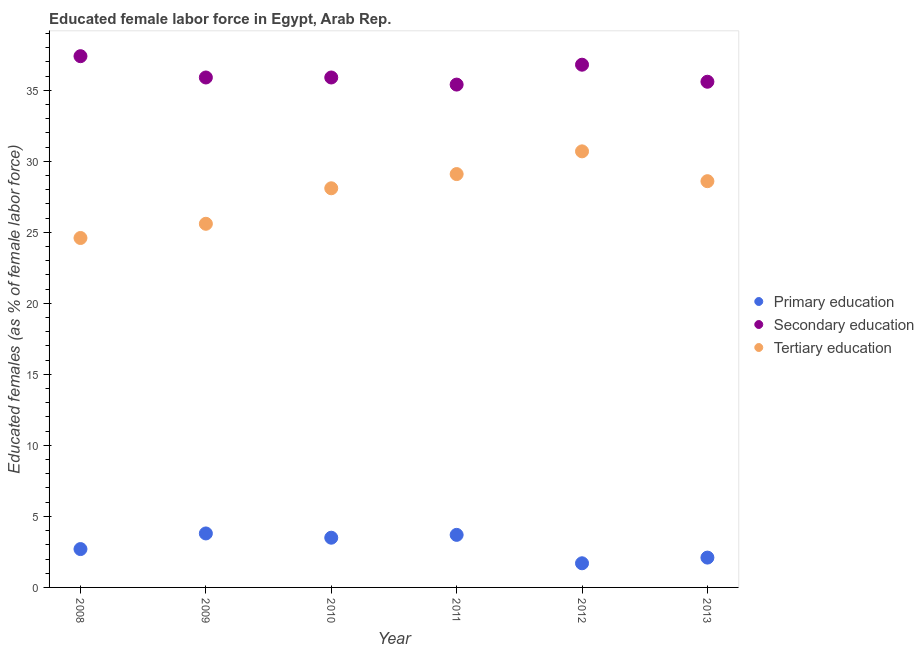Is the number of dotlines equal to the number of legend labels?
Make the answer very short. Yes. What is the percentage of female labor force who received tertiary education in 2012?
Your answer should be compact. 30.7. Across all years, what is the maximum percentage of female labor force who received secondary education?
Keep it short and to the point. 37.4. Across all years, what is the minimum percentage of female labor force who received tertiary education?
Offer a very short reply. 24.6. In which year was the percentage of female labor force who received tertiary education maximum?
Your response must be concise. 2012. What is the total percentage of female labor force who received tertiary education in the graph?
Your response must be concise. 166.7. What is the difference between the percentage of female labor force who received primary education in 2008 and that in 2013?
Offer a very short reply. 0.6. What is the difference between the percentage of female labor force who received secondary education in 2012 and the percentage of female labor force who received tertiary education in 2009?
Keep it short and to the point. 11.2. What is the average percentage of female labor force who received tertiary education per year?
Provide a succinct answer. 27.78. In the year 2013, what is the difference between the percentage of female labor force who received tertiary education and percentage of female labor force who received secondary education?
Keep it short and to the point. -7. In how many years, is the percentage of female labor force who received primary education greater than 2 %?
Your answer should be compact. 5. What is the ratio of the percentage of female labor force who received tertiary education in 2009 to that in 2012?
Your response must be concise. 0.83. What is the difference between the highest and the second highest percentage of female labor force who received tertiary education?
Your answer should be compact. 1.6. What is the difference between the highest and the lowest percentage of female labor force who received primary education?
Offer a very short reply. 2.1. In how many years, is the percentage of female labor force who received tertiary education greater than the average percentage of female labor force who received tertiary education taken over all years?
Your answer should be compact. 4. Is the sum of the percentage of female labor force who received primary education in 2009 and 2012 greater than the maximum percentage of female labor force who received secondary education across all years?
Provide a short and direct response. No. Is it the case that in every year, the sum of the percentage of female labor force who received primary education and percentage of female labor force who received secondary education is greater than the percentage of female labor force who received tertiary education?
Your answer should be very brief. Yes. Is the percentage of female labor force who received primary education strictly greater than the percentage of female labor force who received secondary education over the years?
Provide a succinct answer. No. Is the percentage of female labor force who received secondary education strictly less than the percentage of female labor force who received tertiary education over the years?
Keep it short and to the point. No. What is the difference between two consecutive major ticks on the Y-axis?
Offer a terse response. 5. Does the graph contain any zero values?
Offer a very short reply. No. Does the graph contain grids?
Provide a succinct answer. No. How are the legend labels stacked?
Provide a succinct answer. Vertical. What is the title of the graph?
Your response must be concise. Educated female labor force in Egypt, Arab Rep. What is the label or title of the X-axis?
Provide a succinct answer. Year. What is the label or title of the Y-axis?
Offer a terse response. Educated females (as % of female labor force). What is the Educated females (as % of female labor force) in Primary education in 2008?
Offer a very short reply. 2.7. What is the Educated females (as % of female labor force) in Secondary education in 2008?
Provide a succinct answer. 37.4. What is the Educated females (as % of female labor force) in Tertiary education in 2008?
Your answer should be compact. 24.6. What is the Educated females (as % of female labor force) in Primary education in 2009?
Offer a terse response. 3.8. What is the Educated females (as % of female labor force) in Secondary education in 2009?
Your answer should be very brief. 35.9. What is the Educated females (as % of female labor force) of Tertiary education in 2009?
Offer a very short reply. 25.6. What is the Educated females (as % of female labor force) in Primary education in 2010?
Make the answer very short. 3.5. What is the Educated females (as % of female labor force) of Secondary education in 2010?
Offer a terse response. 35.9. What is the Educated females (as % of female labor force) of Tertiary education in 2010?
Make the answer very short. 28.1. What is the Educated females (as % of female labor force) in Primary education in 2011?
Provide a short and direct response. 3.7. What is the Educated females (as % of female labor force) of Secondary education in 2011?
Ensure brevity in your answer.  35.4. What is the Educated females (as % of female labor force) in Tertiary education in 2011?
Your answer should be very brief. 29.1. What is the Educated females (as % of female labor force) in Primary education in 2012?
Provide a short and direct response. 1.7. What is the Educated females (as % of female labor force) in Secondary education in 2012?
Offer a very short reply. 36.8. What is the Educated females (as % of female labor force) of Tertiary education in 2012?
Ensure brevity in your answer.  30.7. What is the Educated females (as % of female labor force) in Primary education in 2013?
Your answer should be very brief. 2.1. What is the Educated females (as % of female labor force) of Secondary education in 2013?
Offer a very short reply. 35.6. What is the Educated females (as % of female labor force) in Tertiary education in 2013?
Provide a succinct answer. 28.6. Across all years, what is the maximum Educated females (as % of female labor force) of Primary education?
Provide a short and direct response. 3.8. Across all years, what is the maximum Educated females (as % of female labor force) of Secondary education?
Make the answer very short. 37.4. Across all years, what is the maximum Educated females (as % of female labor force) of Tertiary education?
Your response must be concise. 30.7. Across all years, what is the minimum Educated females (as % of female labor force) of Primary education?
Offer a terse response. 1.7. Across all years, what is the minimum Educated females (as % of female labor force) in Secondary education?
Your answer should be compact. 35.4. Across all years, what is the minimum Educated females (as % of female labor force) of Tertiary education?
Ensure brevity in your answer.  24.6. What is the total Educated females (as % of female labor force) in Primary education in the graph?
Offer a very short reply. 17.5. What is the total Educated females (as % of female labor force) in Secondary education in the graph?
Provide a succinct answer. 217. What is the total Educated females (as % of female labor force) in Tertiary education in the graph?
Offer a very short reply. 166.7. What is the difference between the Educated females (as % of female labor force) of Primary education in 2008 and that in 2010?
Offer a very short reply. -0.8. What is the difference between the Educated females (as % of female labor force) of Tertiary education in 2008 and that in 2010?
Your response must be concise. -3.5. What is the difference between the Educated females (as % of female labor force) in Secondary education in 2008 and that in 2011?
Provide a short and direct response. 2. What is the difference between the Educated females (as % of female labor force) in Tertiary education in 2008 and that in 2011?
Your answer should be compact. -4.5. What is the difference between the Educated females (as % of female labor force) in Secondary education in 2008 and that in 2012?
Keep it short and to the point. 0.6. What is the difference between the Educated females (as % of female labor force) of Tertiary education in 2008 and that in 2012?
Your response must be concise. -6.1. What is the difference between the Educated females (as % of female labor force) in Secondary education in 2008 and that in 2013?
Your response must be concise. 1.8. What is the difference between the Educated females (as % of female labor force) of Primary education in 2009 and that in 2010?
Offer a terse response. 0.3. What is the difference between the Educated females (as % of female labor force) in Primary education in 2009 and that in 2011?
Provide a succinct answer. 0.1. What is the difference between the Educated females (as % of female labor force) in Tertiary education in 2009 and that in 2011?
Provide a succinct answer. -3.5. What is the difference between the Educated females (as % of female labor force) in Primary education in 2009 and that in 2012?
Give a very brief answer. 2.1. What is the difference between the Educated females (as % of female labor force) in Secondary education in 2009 and that in 2012?
Offer a terse response. -0.9. What is the difference between the Educated females (as % of female labor force) of Primary education in 2009 and that in 2013?
Give a very brief answer. 1.7. What is the difference between the Educated females (as % of female labor force) in Secondary education in 2009 and that in 2013?
Provide a short and direct response. 0.3. What is the difference between the Educated females (as % of female labor force) in Secondary education in 2010 and that in 2011?
Offer a terse response. 0.5. What is the difference between the Educated females (as % of female labor force) in Primary education in 2010 and that in 2012?
Your response must be concise. 1.8. What is the difference between the Educated females (as % of female labor force) in Tertiary education in 2010 and that in 2012?
Provide a succinct answer. -2.6. What is the difference between the Educated females (as % of female labor force) of Tertiary education in 2010 and that in 2013?
Your response must be concise. -0.5. What is the difference between the Educated females (as % of female labor force) of Primary education in 2011 and that in 2012?
Give a very brief answer. 2. What is the difference between the Educated females (as % of female labor force) in Secondary education in 2011 and that in 2012?
Offer a very short reply. -1.4. What is the difference between the Educated females (as % of female labor force) of Primary education in 2011 and that in 2013?
Offer a terse response. 1.6. What is the difference between the Educated females (as % of female labor force) of Primary education in 2012 and that in 2013?
Ensure brevity in your answer.  -0.4. What is the difference between the Educated females (as % of female labor force) in Tertiary education in 2012 and that in 2013?
Your answer should be compact. 2.1. What is the difference between the Educated females (as % of female labor force) in Primary education in 2008 and the Educated females (as % of female labor force) in Secondary education in 2009?
Provide a short and direct response. -33.2. What is the difference between the Educated females (as % of female labor force) of Primary education in 2008 and the Educated females (as % of female labor force) of Tertiary education in 2009?
Your response must be concise. -22.9. What is the difference between the Educated females (as % of female labor force) of Secondary education in 2008 and the Educated females (as % of female labor force) of Tertiary education in 2009?
Offer a very short reply. 11.8. What is the difference between the Educated females (as % of female labor force) in Primary education in 2008 and the Educated females (as % of female labor force) in Secondary education in 2010?
Ensure brevity in your answer.  -33.2. What is the difference between the Educated females (as % of female labor force) of Primary education in 2008 and the Educated females (as % of female labor force) of Tertiary education in 2010?
Offer a terse response. -25.4. What is the difference between the Educated females (as % of female labor force) in Primary education in 2008 and the Educated females (as % of female labor force) in Secondary education in 2011?
Offer a terse response. -32.7. What is the difference between the Educated females (as % of female labor force) of Primary education in 2008 and the Educated females (as % of female labor force) of Tertiary education in 2011?
Keep it short and to the point. -26.4. What is the difference between the Educated females (as % of female labor force) in Secondary education in 2008 and the Educated females (as % of female labor force) in Tertiary education in 2011?
Offer a very short reply. 8.3. What is the difference between the Educated females (as % of female labor force) in Primary education in 2008 and the Educated females (as % of female labor force) in Secondary education in 2012?
Make the answer very short. -34.1. What is the difference between the Educated females (as % of female labor force) in Primary education in 2008 and the Educated females (as % of female labor force) in Tertiary education in 2012?
Give a very brief answer. -28. What is the difference between the Educated females (as % of female labor force) in Primary education in 2008 and the Educated females (as % of female labor force) in Secondary education in 2013?
Your answer should be compact. -32.9. What is the difference between the Educated females (as % of female labor force) of Primary education in 2008 and the Educated females (as % of female labor force) of Tertiary education in 2013?
Provide a succinct answer. -25.9. What is the difference between the Educated females (as % of female labor force) in Secondary education in 2008 and the Educated females (as % of female labor force) in Tertiary education in 2013?
Provide a short and direct response. 8.8. What is the difference between the Educated females (as % of female labor force) of Primary education in 2009 and the Educated females (as % of female labor force) of Secondary education in 2010?
Make the answer very short. -32.1. What is the difference between the Educated females (as % of female labor force) of Primary education in 2009 and the Educated females (as % of female labor force) of Tertiary education in 2010?
Provide a succinct answer. -24.3. What is the difference between the Educated females (as % of female labor force) in Primary education in 2009 and the Educated females (as % of female labor force) in Secondary education in 2011?
Your response must be concise. -31.6. What is the difference between the Educated females (as % of female labor force) in Primary education in 2009 and the Educated females (as % of female labor force) in Tertiary education in 2011?
Your answer should be compact. -25.3. What is the difference between the Educated females (as % of female labor force) of Primary education in 2009 and the Educated females (as % of female labor force) of Secondary education in 2012?
Ensure brevity in your answer.  -33. What is the difference between the Educated females (as % of female labor force) in Primary education in 2009 and the Educated females (as % of female labor force) in Tertiary education in 2012?
Offer a very short reply. -26.9. What is the difference between the Educated females (as % of female labor force) of Primary education in 2009 and the Educated females (as % of female labor force) of Secondary education in 2013?
Your answer should be very brief. -31.8. What is the difference between the Educated females (as % of female labor force) of Primary education in 2009 and the Educated females (as % of female labor force) of Tertiary education in 2013?
Your answer should be very brief. -24.8. What is the difference between the Educated females (as % of female labor force) in Primary education in 2010 and the Educated females (as % of female labor force) in Secondary education in 2011?
Provide a succinct answer. -31.9. What is the difference between the Educated females (as % of female labor force) in Primary education in 2010 and the Educated females (as % of female labor force) in Tertiary education in 2011?
Make the answer very short. -25.6. What is the difference between the Educated females (as % of female labor force) of Primary education in 2010 and the Educated females (as % of female labor force) of Secondary education in 2012?
Keep it short and to the point. -33.3. What is the difference between the Educated females (as % of female labor force) of Primary education in 2010 and the Educated females (as % of female labor force) of Tertiary education in 2012?
Your answer should be compact. -27.2. What is the difference between the Educated females (as % of female labor force) of Primary education in 2010 and the Educated females (as % of female labor force) of Secondary education in 2013?
Offer a terse response. -32.1. What is the difference between the Educated females (as % of female labor force) of Primary education in 2010 and the Educated females (as % of female labor force) of Tertiary education in 2013?
Your answer should be compact. -25.1. What is the difference between the Educated females (as % of female labor force) in Secondary education in 2010 and the Educated females (as % of female labor force) in Tertiary education in 2013?
Your answer should be very brief. 7.3. What is the difference between the Educated females (as % of female labor force) in Primary education in 2011 and the Educated females (as % of female labor force) in Secondary education in 2012?
Make the answer very short. -33.1. What is the difference between the Educated females (as % of female labor force) of Primary education in 2011 and the Educated females (as % of female labor force) of Tertiary education in 2012?
Your answer should be compact. -27. What is the difference between the Educated females (as % of female labor force) in Primary education in 2011 and the Educated females (as % of female labor force) in Secondary education in 2013?
Your answer should be compact. -31.9. What is the difference between the Educated females (as % of female labor force) in Primary education in 2011 and the Educated females (as % of female labor force) in Tertiary education in 2013?
Ensure brevity in your answer.  -24.9. What is the difference between the Educated females (as % of female labor force) of Primary education in 2012 and the Educated females (as % of female labor force) of Secondary education in 2013?
Your answer should be compact. -33.9. What is the difference between the Educated females (as % of female labor force) of Primary education in 2012 and the Educated females (as % of female labor force) of Tertiary education in 2013?
Your answer should be very brief. -26.9. What is the average Educated females (as % of female labor force) in Primary education per year?
Give a very brief answer. 2.92. What is the average Educated females (as % of female labor force) of Secondary education per year?
Make the answer very short. 36.17. What is the average Educated females (as % of female labor force) in Tertiary education per year?
Offer a terse response. 27.78. In the year 2008, what is the difference between the Educated females (as % of female labor force) of Primary education and Educated females (as % of female labor force) of Secondary education?
Your response must be concise. -34.7. In the year 2008, what is the difference between the Educated females (as % of female labor force) of Primary education and Educated females (as % of female labor force) of Tertiary education?
Provide a short and direct response. -21.9. In the year 2008, what is the difference between the Educated females (as % of female labor force) of Secondary education and Educated females (as % of female labor force) of Tertiary education?
Your response must be concise. 12.8. In the year 2009, what is the difference between the Educated females (as % of female labor force) of Primary education and Educated females (as % of female labor force) of Secondary education?
Give a very brief answer. -32.1. In the year 2009, what is the difference between the Educated females (as % of female labor force) in Primary education and Educated females (as % of female labor force) in Tertiary education?
Provide a short and direct response. -21.8. In the year 2009, what is the difference between the Educated females (as % of female labor force) in Secondary education and Educated females (as % of female labor force) in Tertiary education?
Provide a short and direct response. 10.3. In the year 2010, what is the difference between the Educated females (as % of female labor force) of Primary education and Educated females (as % of female labor force) of Secondary education?
Your answer should be very brief. -32.4. In the year 2010, what is the difference between the Educated females (as % of female labor force) of Primary education and Educated females (as % of female labor force) of Tertiary education?
Ensure brevity in your answer.  -24.6. In the year 2011, what is the difference between the Educated females (as % of female labor force) of Primary education and Educated females (as % of female labor force) of Secondary education?
Keep it short and to the point. -31.7. In the year 2011, what is the difference between the Educated females (as % of female labor force) in Primary education and Educated females (as % of female labor force) in Tertiary education?
Provide a succinct answer. -25.4. In the year 2011, what is the difference between the Educated females (as % of female labor force) in Secondary education and Educated females (as % of female labor force) in Tertiary education?
Your response must be concise. 6.3. In the year 2012, what is the difference between the Educated females (as % of female labor force) in Primary education and Educated females (as % of female labor force) in Secondary education?
Make the answer very short. -35.1. In the year 2012, what is the difference between the Educated females (as % of female labor force) in Secondary education and Educated females (as % of female labor force) in Tertiary education?
Offer a very short reply. 6.1. In the year 2013, what is the difference between the Educated females (as % of female labor force) of Primary education and Educated females (as % of female labor force) of Secondary education?
Offer a terse response. -33.5. In the year 2013, what is the difference between the Educated females (as % of female labor force) in Primary education and Educated females (as % of female labor force) in Tertiary education?
Offer a very short reply. -26.5. What is the ratio of the Educated females (as % of female labor force) in Primary education in 2008 to that in 2009?
Your answer should be very brief. 0.71. What is the ratio of the Educated females (as % of female labor force) in Secondary education in 2008 to that in 2009?
Your answer should be compact. 1.04. What is the ratio of the Educated females (as % of female labor force) of Tertiary education in 2008 to that in 2009?
Offer a terse response. 0.96. What is the ratio of the Educated females (as % of female labor force) of Primary education in 2008 to that in 2010?
Offer a very short reply. 0.77. What is the ratio of the Educated females (as % of female labor force) of Secondary education in 2008 to that in 2010?
Your answer should be very brief. 1.04. What is the ratio of the Educated females (as % of female labor force) of Tertiary education in 2008 to that in 2010?
Offer a very short reply. 0.88. What is the ratio of the Educated females (as % of female labor force) of Primary education in 2008 to that in 2011?
Ensure brevity in your answer.  0.73. What is the ratio of the Educated females (as % of female labor force) of Secondary education in 2008 to that in 2011?
Offer a terse response. 1.06. What is the ratio of the Educated females (as % of female labor force) in Tertiary education in 2008 to that in 2011?
Your answer should be very brief. 0.85. What is the ratio of the Educated females (as % of female labor force) in Primary education in 2008 to that in 2012?
Your answer should be compact. 1.59. What is the ratio of the Educated females (as % of female labor force) of Secondary education in 2008 to that in 2012?
Make the answer very short. 1.02. What is the ratio of the Educated females (as % of female labor force) in Tertiary education in 2008 to that in 2012?
Give a very brief answer. 0.8. What is the ratio of the Educated females (as % of female labor force) in Primary education in 2008 to that in 2013?
Provide a short and direct response. 1.29. What is the ratio of the Educated females (as % of female labor force) in Secondary education in 2008 to that in 2013?
Ensure brevity in your answer.  1.05. What is the ratio of the Educated females (as % of female labor force) of Tertiary education in 2008 to that in 2013?
Keep it short and to the point. 0.86. What is the ratio of the Educated females (as % of female labor force) of Primary education in 2009 to that in 2010?
Give a very brief answer. 1.09. What is the ratio of the Educated females (as % of female labor force) in Tertiary education in 2009 to that in 2010?
Your answer should be very brief. 0.91. What is the ratio of the Educated females (as % of female labor force) of Primary education in 2009 to that in 2011?
Your response must be concise. 1.03. What is the ratio of the Educated females (as % of female labor force) of Secondary education in 2009 to that in 2011?
Your response must be concise. 1.01. What is the ratio of the Educated females (as % of female labor force) in Tertiary education in 2009 to that in 2011?
Offer a very short reply. 0.88. What is the ratio of the Educated females (as % of female labor force) of Primary education in 2009 to that in 2012?
Make the answer very short. 2.24. What is the ratio of the Educated females (as % of female labor force) in Secondary education in 2009 to that in 2012?
Make the answer very short. 0.98. What is the ratio of the Educated females (as % of female labor force) in Tertiary education in 2009 to that in 2012?
Your answer should be compact. 0.83. What is the ratio of the Educated females (as % of female labor force) in Primary education in 2009 to that in 2013?
Offer a terse response. 1.81. What is the ratio of the Educated females (as % of female labor force) in Secondary education in 2009 to that in 2013?
Your response must be concise. 1.01. What is the ratio of the Educated females (as % of female labor force) of Tertiary education in 2009 to that in 2013?
Your answer should be very brief. 0.9. What is the ratio of the Educated females (as % of female labor force) of Primary education in 2010 to that in 2011?
Your answer should be compact. 0.95. What is the ratio of the Educated females (as % of female labor force) in Secondary education in 2010 to that in 2011?
Offer a terse response. 1.01. What is the ratio of the Educated females (as % of female labor force) of Tertiary education in 2010 to that in 2011?
Give a very brief answer. 0.97. What is the ratio of the Educated females (as % of female labor force) in Primary education in 2010 to that in 2012?
Provide a short and direct response. 2.06. What is the ratio of the Educated females (as % of female labor force) of Secondary education in 2010 to that in 2012?
Your answer should be very brief. 0.98. What is the ratio of the Educated females (as % of female labor force) of Tertiary education in 2010 to that in 2012?
Ensure brevity in your answer.  0.92. What is the ratio of the Educated females (as % of female labor force) of Secondary education in 2010 to that in 2013?
Provide a succinct answer. 1.01. What is the ratio of the Educated females (as % of female labor force) in Tertiary education in 2010 to that in 2013?
Keep it short and to the point. 0.98. What is the ratio of the Educated females (as % of female labor force) in Primary education in 2011 to that in 2012?
Make the answer very short. 2.18. What is the ratio of the Educated females (as % of female labor force) in Tertiary education in 2011 to that in 2012?
Give a very brief answer. 0.95. What is the ratio of the Educated females (as % of female labor force) in Primary education in 2011 to that in 2013?
Provide a short and direct response. 1.76. What is the ratio of the Educated females (as % of female labor force) in Tertiary education in 2011 to that in 2013?
Give a very brief answer. 1.02. What is the ratio of the Educated females (as % of female labor force) in Primary education in 2012 to that in 2013?
Offer a terse response. 0.81. What is the ratio of the Educated females (as % of female labor force) in Secondary education in 2012 to that in 2013?
Ensure brevity in your answer.  1.03. What is the ratio of the Educated females (as % of female labor force) in Tertiary education in 2012 to that in 2013?
Provide a succinct answer. 1.07. What is the difference between the highest and the second highest Educated females (as % of female labor force) of Tertiary education?
Offer a terse response. 1.6. 